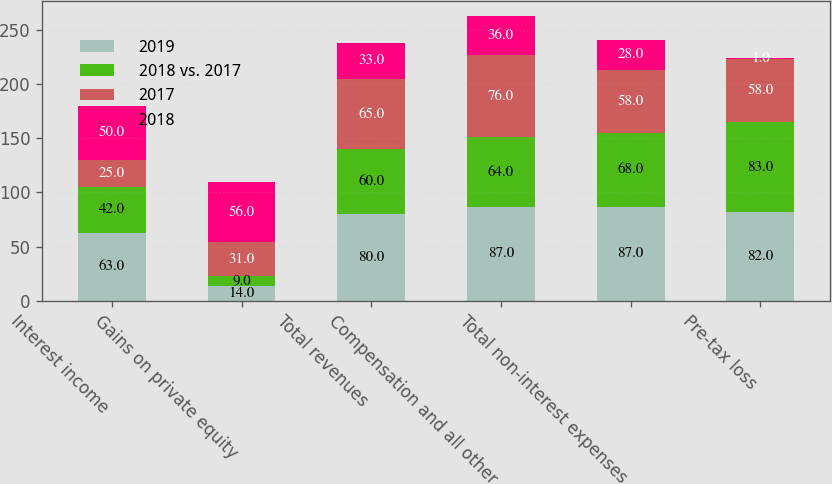Convert chart. <chart><loc_0><loc_0><loc_500><loc_500><stacked_bar_chart><ecel><fcel>Interest income<fcel>Gains on private equity<fcel>Total revenues<fcel>Compensation and all other<fcel>Total non-interest expenses<fcel>Pre-tax loss<nl><fcel>2019<fcel>63<fcel>14<fcel>80<fcel>87<fcel>87<fcel>82<nl><fcel>2018 vs. 2017<fcel>42<fcel>9<fcel>60<fcel>64<fcel>68<fcel>83<nl><fcel>2017<fcel>25<fcel>31<fcel>65<fcel>76<fcel>58<fcel>58<nl><fcel>2018<fcel>50<fcel>56<fcel>33<fcel>36<fcel>28<fcel>1<nl></chart> 